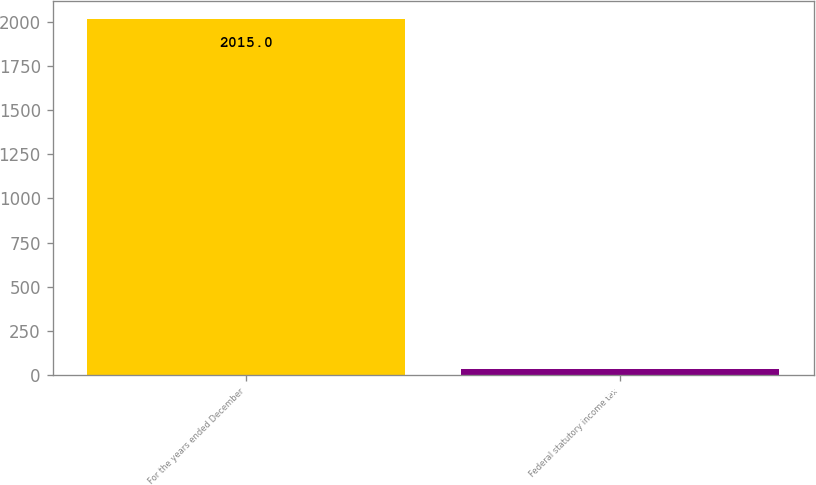<chart> <loc_0><loc_0><loc_500><loc_500><bar_chart><fcel>For the years ended December<fcel>Federal statutory income tax<nl><fcel>2015<fcel>35<nl></chart> 